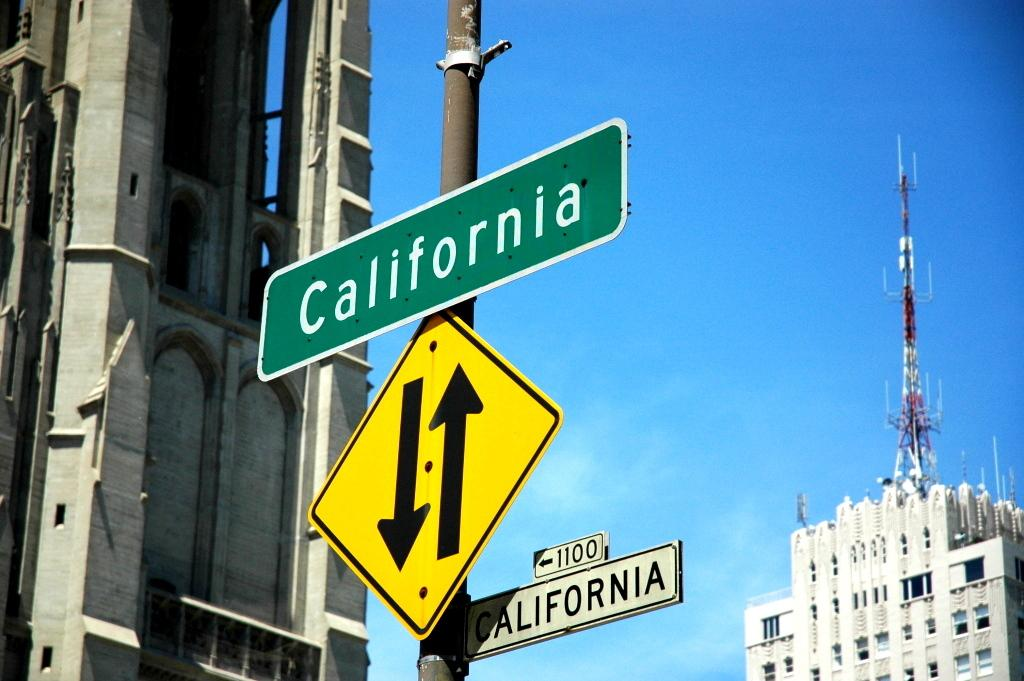Provide a one-sentence caption for the provided image. A gray building stands by a street sign for the 1100 block of California. 